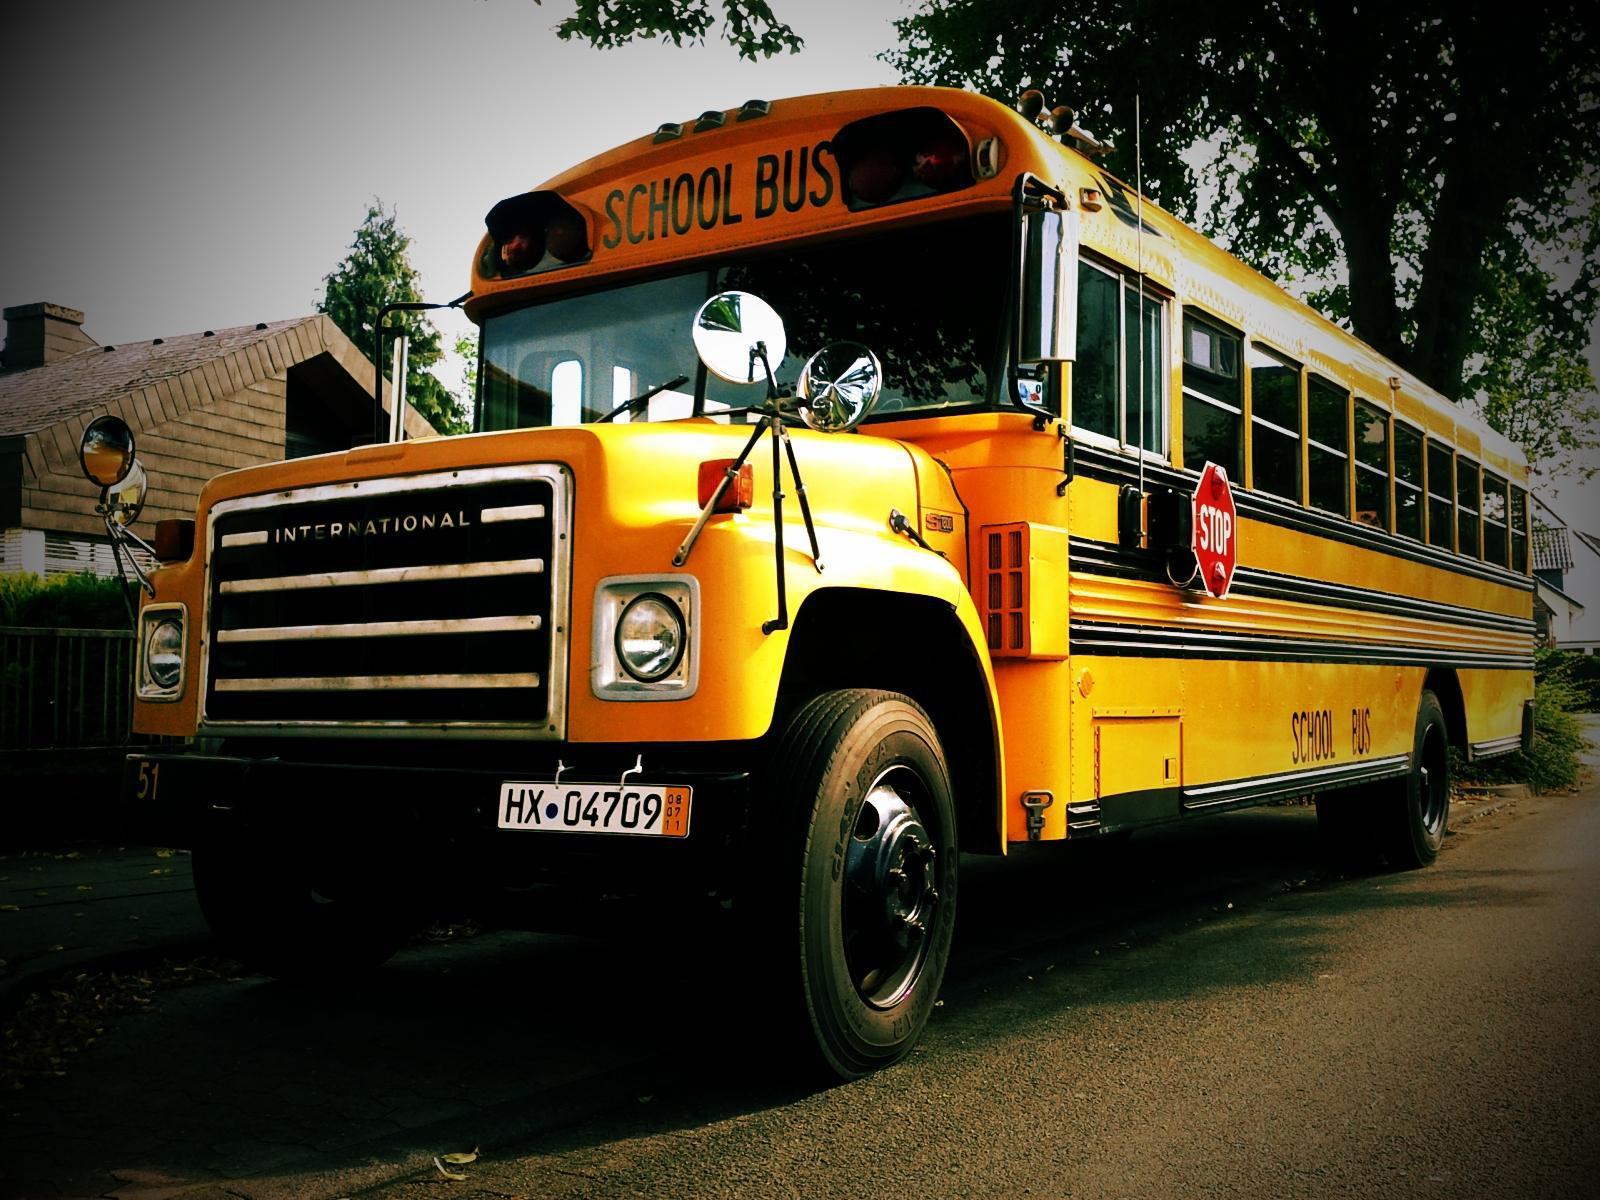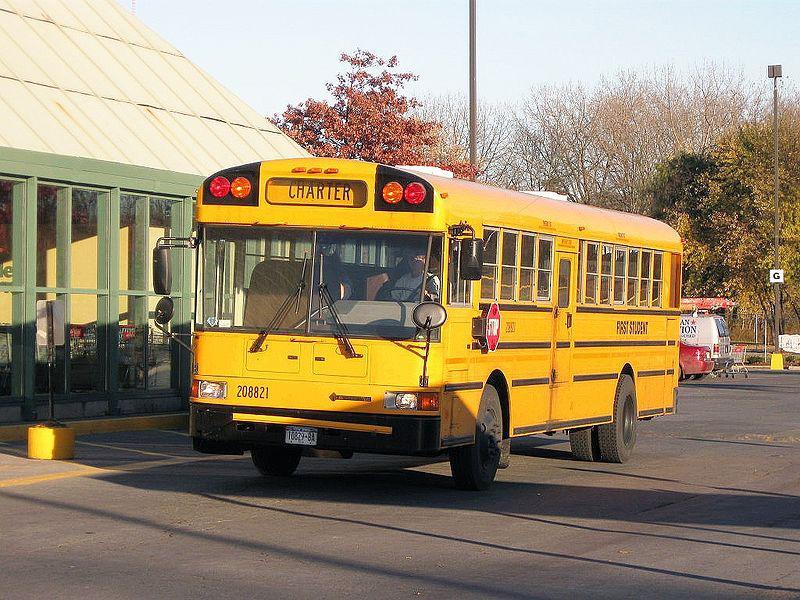The first image is the image on the left, the second image is the image on the right. Evaluate the accuracy of this statement regarding the images: "At least one of the buses' stop signs is visible.". Is it true? Answer yes or no. Yes. The first image is the image on the left, the second image is the image on the right. For the images shown, is this caption "One image shows a flat-front yellow bus, and the other image shows a bus with a hood that projects below the windshield, and all buses are facing somewhat forward." true? Answer yes or no. Yes. 